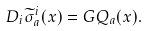<formula> <loc_0><loc_0><loc_500><loc_500>D _ { i } \widetilde { \sigma } ^ { i } _ { a } ( x ) = G Q _ { a } ( x ) .</formula> 